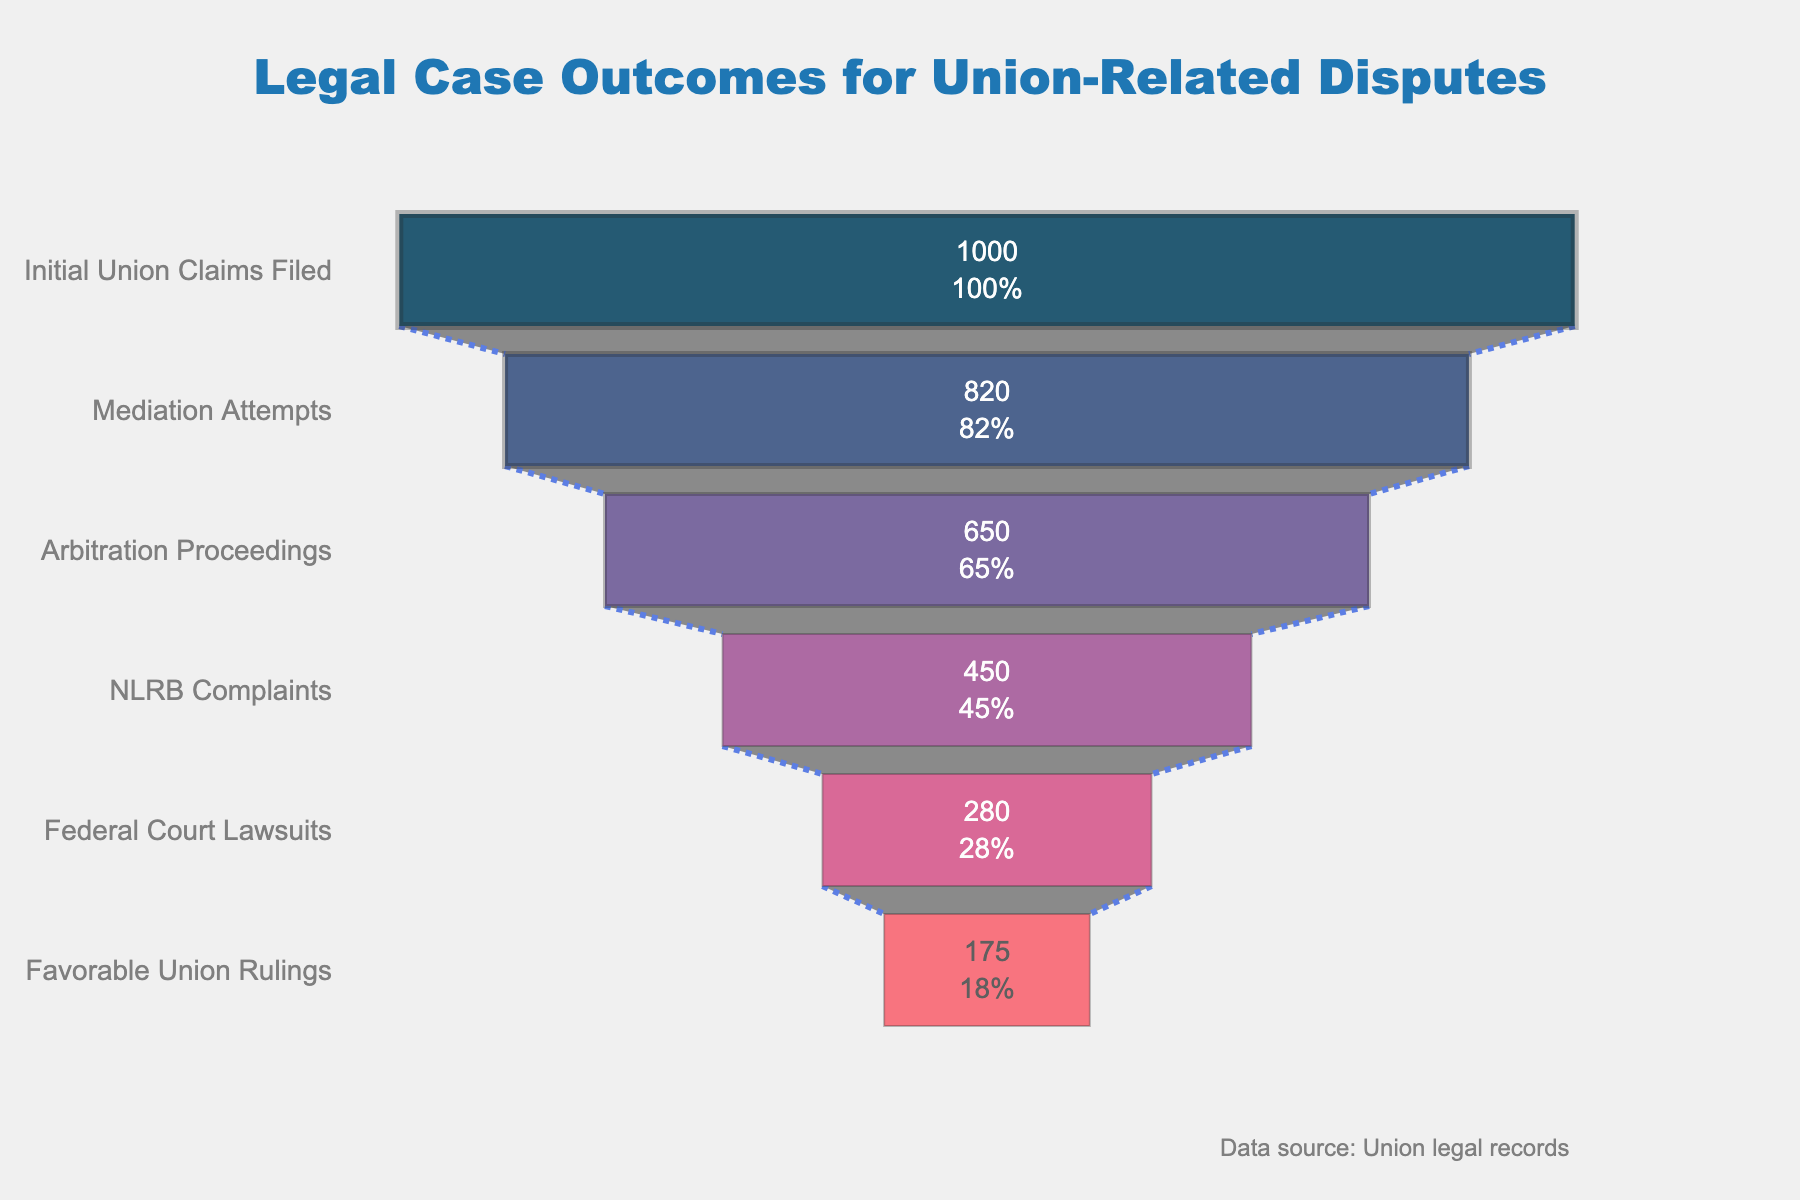What's the title of the figure? The title of the figure is usually displayed at the top. In this case, it reads "Legal Case Outcomes for Union-Related Disputes".
Answer: Legal Case Outcomes for Union-Related Disputes How many stages are there in the funnel chart? By looking at the stages listed on the vertical axis, we can count them to find the total number of stages. The stages are "Initial Union Claims Filed", "Mediation Attempts", "Arbitration Proceedings", "NLRB Complaints", "Federal Court Lawsuits", and "Favorable Union Rulings", making a total of six stages.
Answer: 6 Which stage has the highest number of cases? By looking at the horizontal length of the bars, the longest corresponds to the stage "Initial Union Claims Filed", which has 1000 cases.
Answer: Initial Union Claims Filed What percentage of cases proceed to Mediation Attempts? From the chart, we see the "Mediation Attempts" bar and its percentage representation. It is labeled as 82%.
Answer: 82% What is the difference in the number of cases between Mediation Attempts and Arbitration Proceedings? To find the difference, we refer to the number of cases at each stage: Mediation Attempts have 820 cases and Arbitration Proceedings have 650 cases. The difference is 820 - 650 = 170.
Answer: 170 What percentage of the initial union claims result in NLRB Complaints? The bar for "NLRB Complaints" is labeled with its percentage of the initial claims, which is 45%.
Answer: 45% Which stage has a lower number of cases, Federal Court Lawsuits or Arbitration Proceedings? By comparing the lengths of the bars: Arbitration Proceedings have 650 cases, while Federal Court Lawsuits have 280 cases. Thus, Federal Court Lawsuits have fewer cases.
Answer: Federal Court Lawsuits What percentage of the initial union claims result in Favorable Union Rulings? The "Favorable Union Rulings" bar shows its percentage, which is 17.5%.
Answer: 17.5% Compare the success rate (ending in Favorable Union Rulings) for union-related claims that proceeded to Federal Court Lawsuits against the initial claims. To find the success rate for Federal Court Lawsuits: from the chart, we see there are 280 Federal Court Lawsuits, leading to 175 Favorable Union Rulings. The success rate is (175/280) * 100 ≈ 62.5%. This is higher compared to the overall favorable ruling rate of 17.5% of the initial claims.
Answer: Federal Court: 62.5%, Initial Claims: 17.5% What is the cumulative percentage drop from Initial Union Claims Filed to Mediation Attempts, Arbitration Proceedings, NLRB Complaints, Federal Court Lawsuits, and Favorable Union Rulings? The cumulative percentage drop can be seen by sequentially subtracting the percentages: 
From Initial Union Claims Filed to Mediation Attempts: 100% - 82% = 18%, 
to Arbitration Proceedings: 82% - 65% = 17%, 
to NLRB Complaints: 65% - 45% = 20%, 
to Federal Court Lawsuits: 45% - 28% = 17%, 
to Favorable Union Rulings: 28% - 17.5% = 10.5%.
Summing these percentages: 18% + 17% + 20% + 17% + 10.5% = 82.5%.
Answer: 82.5% 